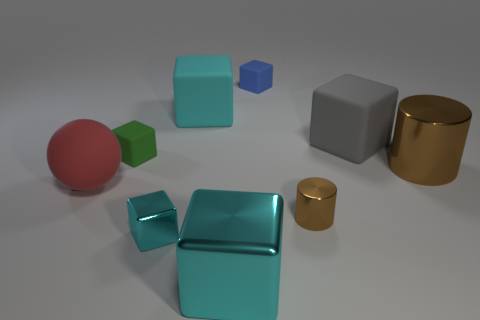There is a object that is left of the tiny matte cube that is in front of the blue cube that is behind the big metallic block; what is its material?
Ensure brevity in your answer.  Rubber. How many things are either rubber cubes that are to the right of the large cyan shiny object or blocks left of the blue block?
Offer a very short reply. 6. What is the material of the other thing that is the same shape as the tiny brown object?
Give a very brief answer. Metal. What number of matte things are either gray things or big cyan objects?
Give a very brief answer. 2. The brown object that is the same material as the small brown cylinder is what shape?
Offer a very short reply. Cylinder. What number of small cyan things have the same shape as the large cyan metal object?
Ensure brevity in your answer.  1. There is a small matte object behind the tiny green thing; is its shape the same as the big cyan object that is in front of the matte ball?
Your answer should be compact. Yes. What number of things are small gray matte spheres or objects in front of the large brown cylinder?
Give a very brief answer. 4. There is a thing that is the same color as the large shiny cylinder; what is its shape?
Offer a terse response. Cylinder. How many rubber things are the same size as the matte ball?
Keep it short and to the point. 2. 